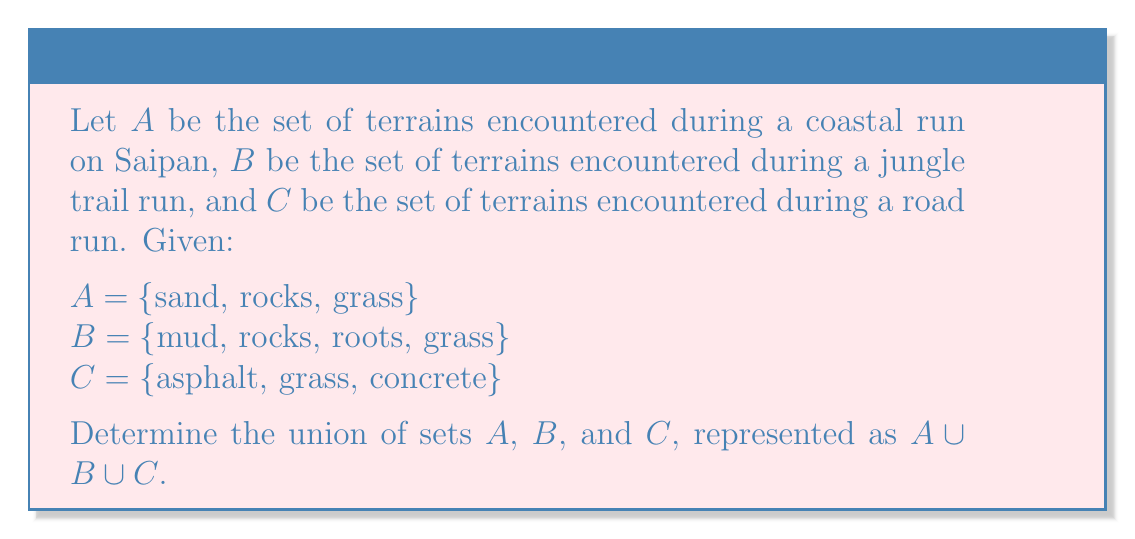Give your solution to this math problem. To find the union of sets A, B, and C, we need to combine all unique elements from all three sets. Let's approach this step-by-step:

1. First, let's list all elements from set A:
   {sand, rocks, grass}

2. Now, let's add any new elements from set B that are not already in our list:
   {sand, rocks, grass, mud, roots}

3. Finally, let's add any new elements from set C that are not already in our list:
   {sand, rocks, grass, mud, roots, asphalt, concrete}

The union of sets A, B, and C includes all unique elements that appear in at least one of the sets. In set notation, this is written as:

$A \cup B \cup C = \{x | x \in A \text{ or } x \in B \text{ or } x \in C\}$

Where $x$ represents any element in the resulting set.
Answer: $A \cup B \cup C = \{sand, rocks, grass, mud, roots, asphalt, concrete\}$ 